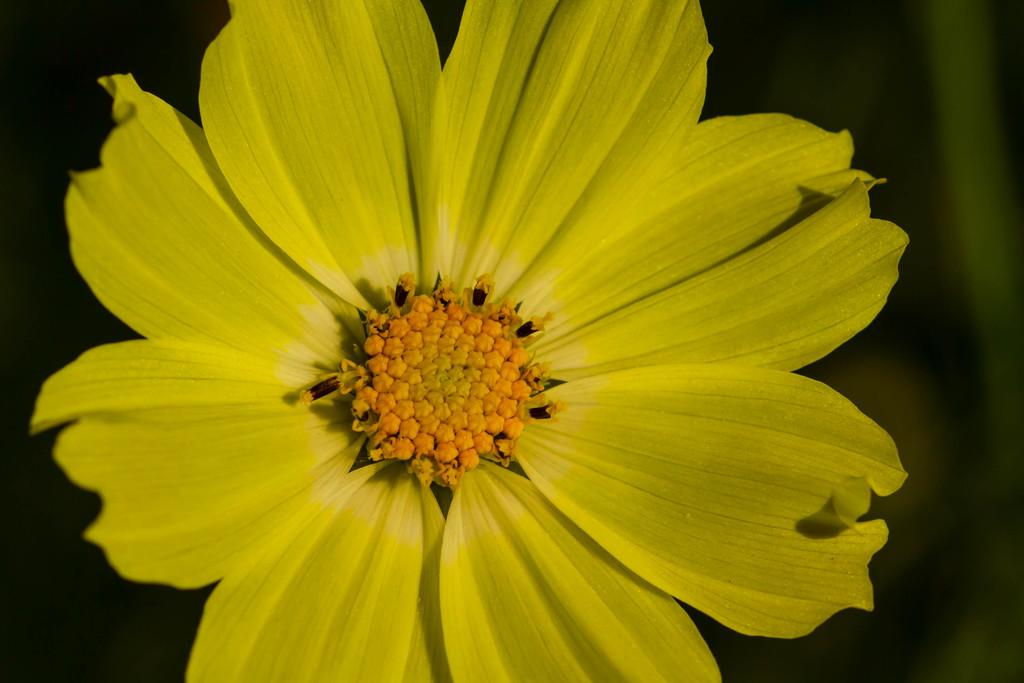What is the main subject of the picture? There is a flower in the picture. Can you describe the background of the image? The background of the image is blurred. What type of account does the flower have in the image? There is no mention of an account in the image, as it features a flower and a blurred background. How many teeth can be seen in the mouth of the flower in the image? Flowers do not have mouths or teeth, so this question cannot be answered based on the image. 